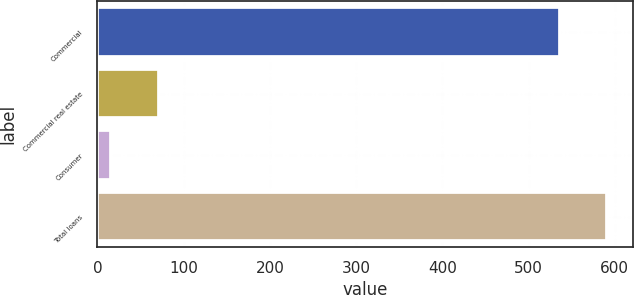Convert chart to OTSL. <chart><loc_0><loc_0><loc_500><loc_500><bar_chart><fcel>Commercial<fcel>Commercial real estate<fcel>Consumer<fcel>Total loans<nl><fcel>536<fcel>71.3<fcel>16<fcel>591.3<nl></chart> 